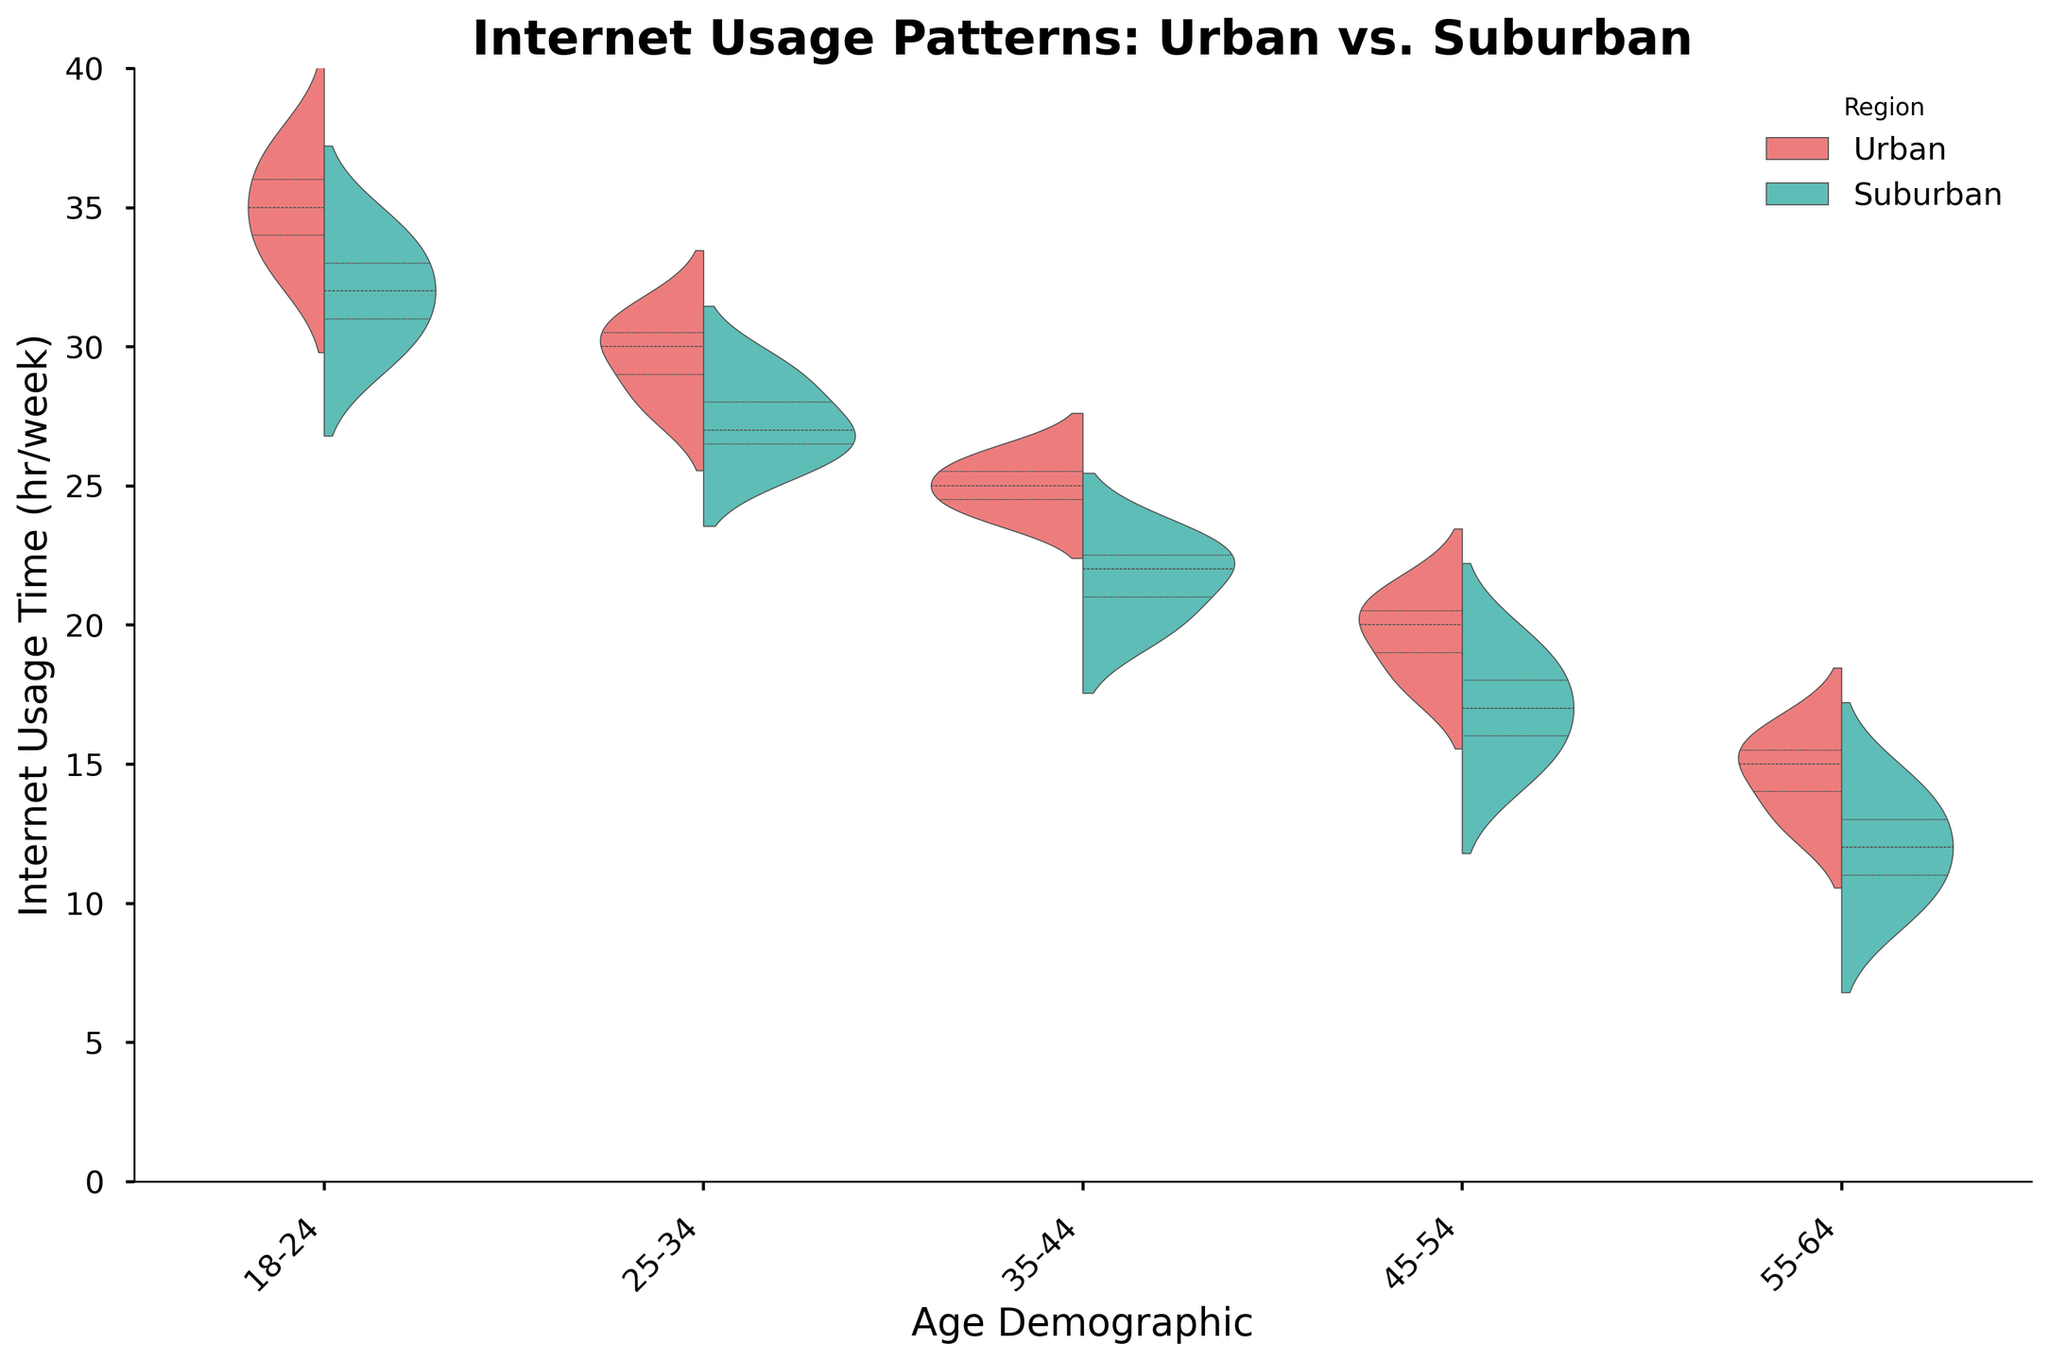What is the title of the figure? The title is usually at the top of the figure and should be easily readable. It gives an overview of what the figure represents.
Answer: Internet Usage Patterns: Urban vs. Suburban What are the labels of the x-axis and y-axis? The x-axis label represents the categories, while the y-axis label represents the numerical values.
Answer: Age Demographic (x-axis), Internet Usage Time (hr/week) (y-axis) Which region has a higher median internet usage time for the 18-24 age demographic? Look at the inner quartile lines within the violin plots for both regions at the 18-24 age demographic. The one with the higher middle line indicates a higher median.
Answer: Urban How do the internet usage patterns differ between the 45-54 age demographic in urban and suburban regions? Compare the shapes and distributions of the violins for the 45-54 demographic in both regions. Urban regions may show different usage patterns compared to suburban ones.
Answer: Urban shows higher usage with a larger spread Which age demographic shows the least difference in internet usage patterns between urban and suburban regions? Compare the violin plots across all age demographics. The pair with the most similar shapes and spreads indicates the least difference.
Answer: 55-64 In which age demographic is the internet usage time most diverse in urban regions? Look at the spread of the violin plots for urban regions across all age demographics. The most vertically spread plot indicates the most diversity.
Answer: 18-24 What is the range of internet usage times for suburban 25-34 age demographic? Identify the range by measuring from the bottom to the top of the violin plot for the suburban region in the 25-34 age demographic.
Answer: 26 to 29 hours Is the internet usage generally higher in urban or suburban regions? Look at the median lines within the violin plots for both types of regions across all age demographics. The region with consistently higher medians indicates generally higher usage.
Answer: Urban Which age group shows a significant drop in internet usage from urban to suburban regions? Compare the median lines between urban and suburban regions for each age demographic. The age group with the largest drop represents a significant decline.
Answer: 18-24 